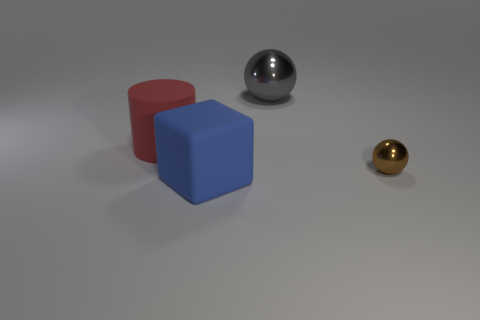Add 1 large red cylinders. How many objects exist? 5 Subtract all cyan cylinders. Subtract all blue blocks. How many cylinders are left? 1 Subtract all cylinders. How many objects are left? 3 Subtract 0 cyan cylinders. How many objects are left? 4 Subtract all large blue rubber blocks. Subtract all metallic blocks. How many objects are left? 3 Add 2 large red matte cylinders. How many large red matte cylinders are left? 3 Add 2 gray spheres. How many gray spheres exist? 3 